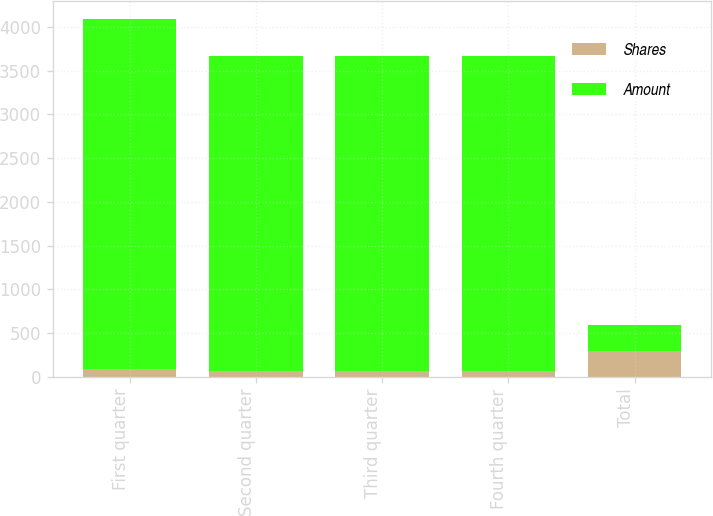Convert chart to OTSL. <chart><loc_0><loc_0><loc_500><loc_500><stacked_bar_chart><ecel><fcel>First quarter<fcel>Second quarter<fcel>Third quarter<fcel>Fourth quarter<fcel>Total<nl><fcel>Shares<fcel>89<fcel>66<fcel>69<fcel>70<fcel>294<nl><fcel>Amount<fcel>4000<fcel>3600<fcel>3600<fcel>3600<fcel>294<nl></chart> 